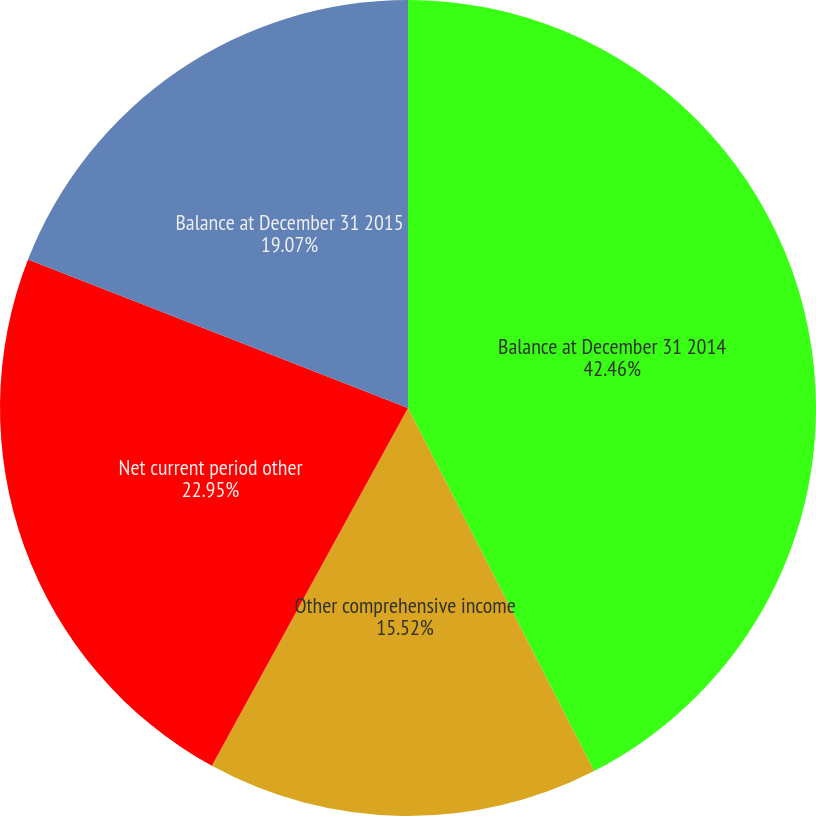Convert chart to OTSL. <chart><loc_0><loc_0><loc_500><loc_500><pie_chart><fcel>Balance at December 31 2014<fcel>Other comprehensive income<fcel>Net current period other<fcel>Balance at December 31 2015<nl><fcel>42.46%<fcel>15.52%<fcel>22.95%<fcel>19.07%<nl></chart> 